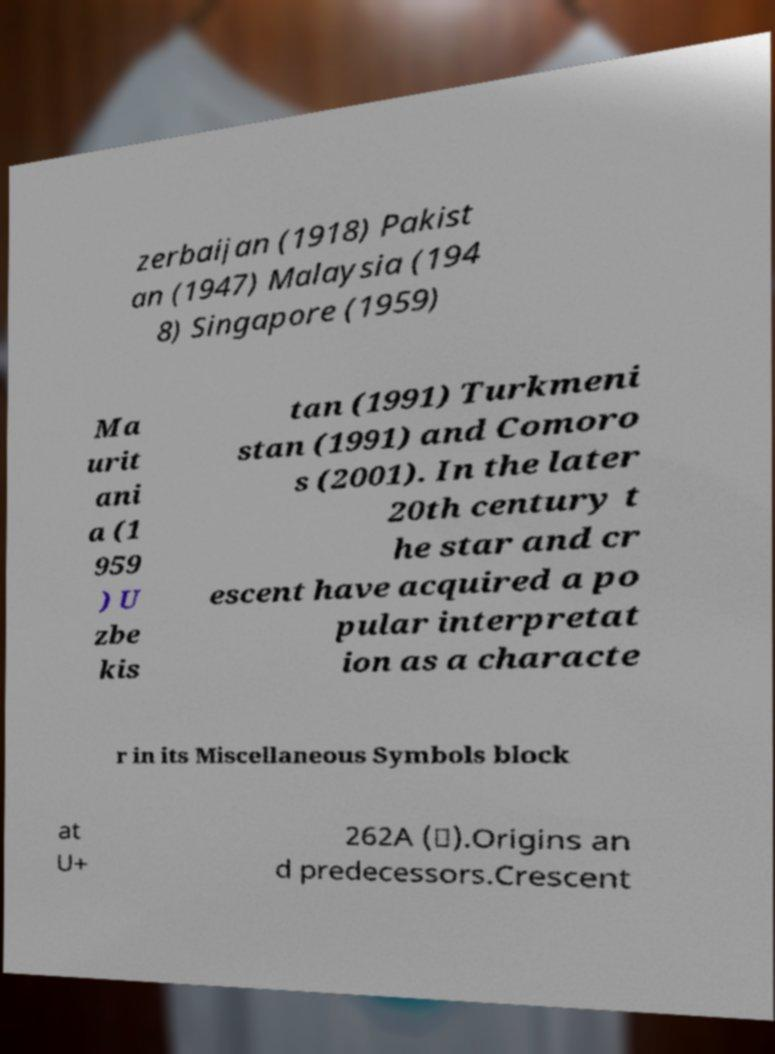Can you read and provide the text displayed in the image?This photo seems to have some interesting text. Can you extract and type it out for me? zerbaijan (1918) Pakist an (1947) Malaysia (194 8) Singapore (1959) Ma urit ani a (1 959 ) U zbe kis tan (1991) Turkmeni stan (1991) and Comoro s (2001). In the later 20th century t he star and cr escent have acquired a po pular interpretat ion as a characte r in its Miscellaneous Symbols block at U+ 262A (☪).Origins an d predecessors.Crescent 